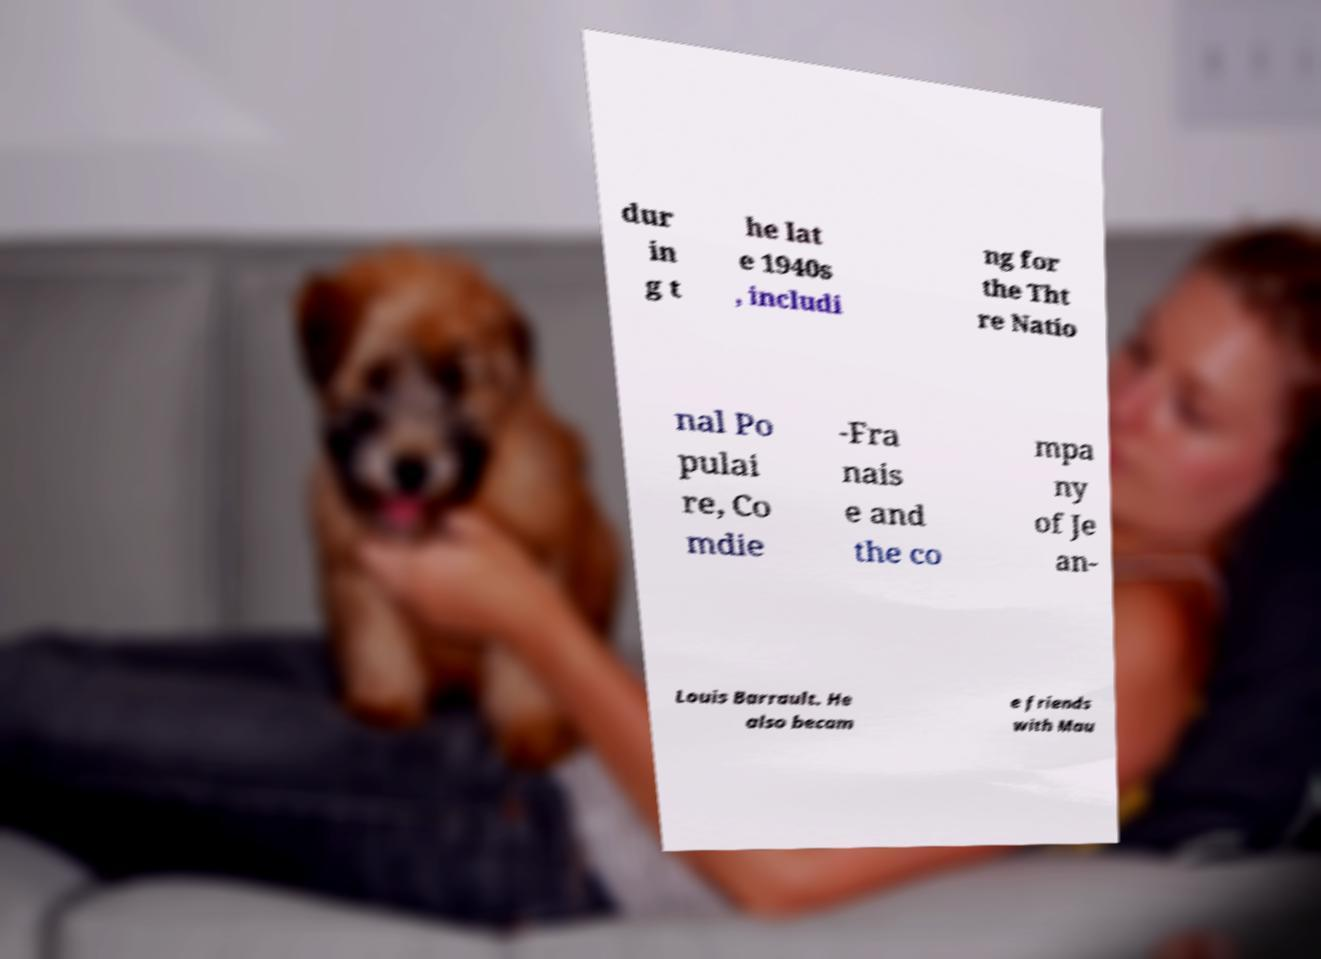What messages or text are displayed in this image? I need them in a readable, typed format. dur in g t he lat e 1940s , includi ng for the Tht re Natio nal Po pulai re, Co mdie -Fra nais e and the co mpa ny of Je an- Louis Barrault. He also becam e friends with Mau 